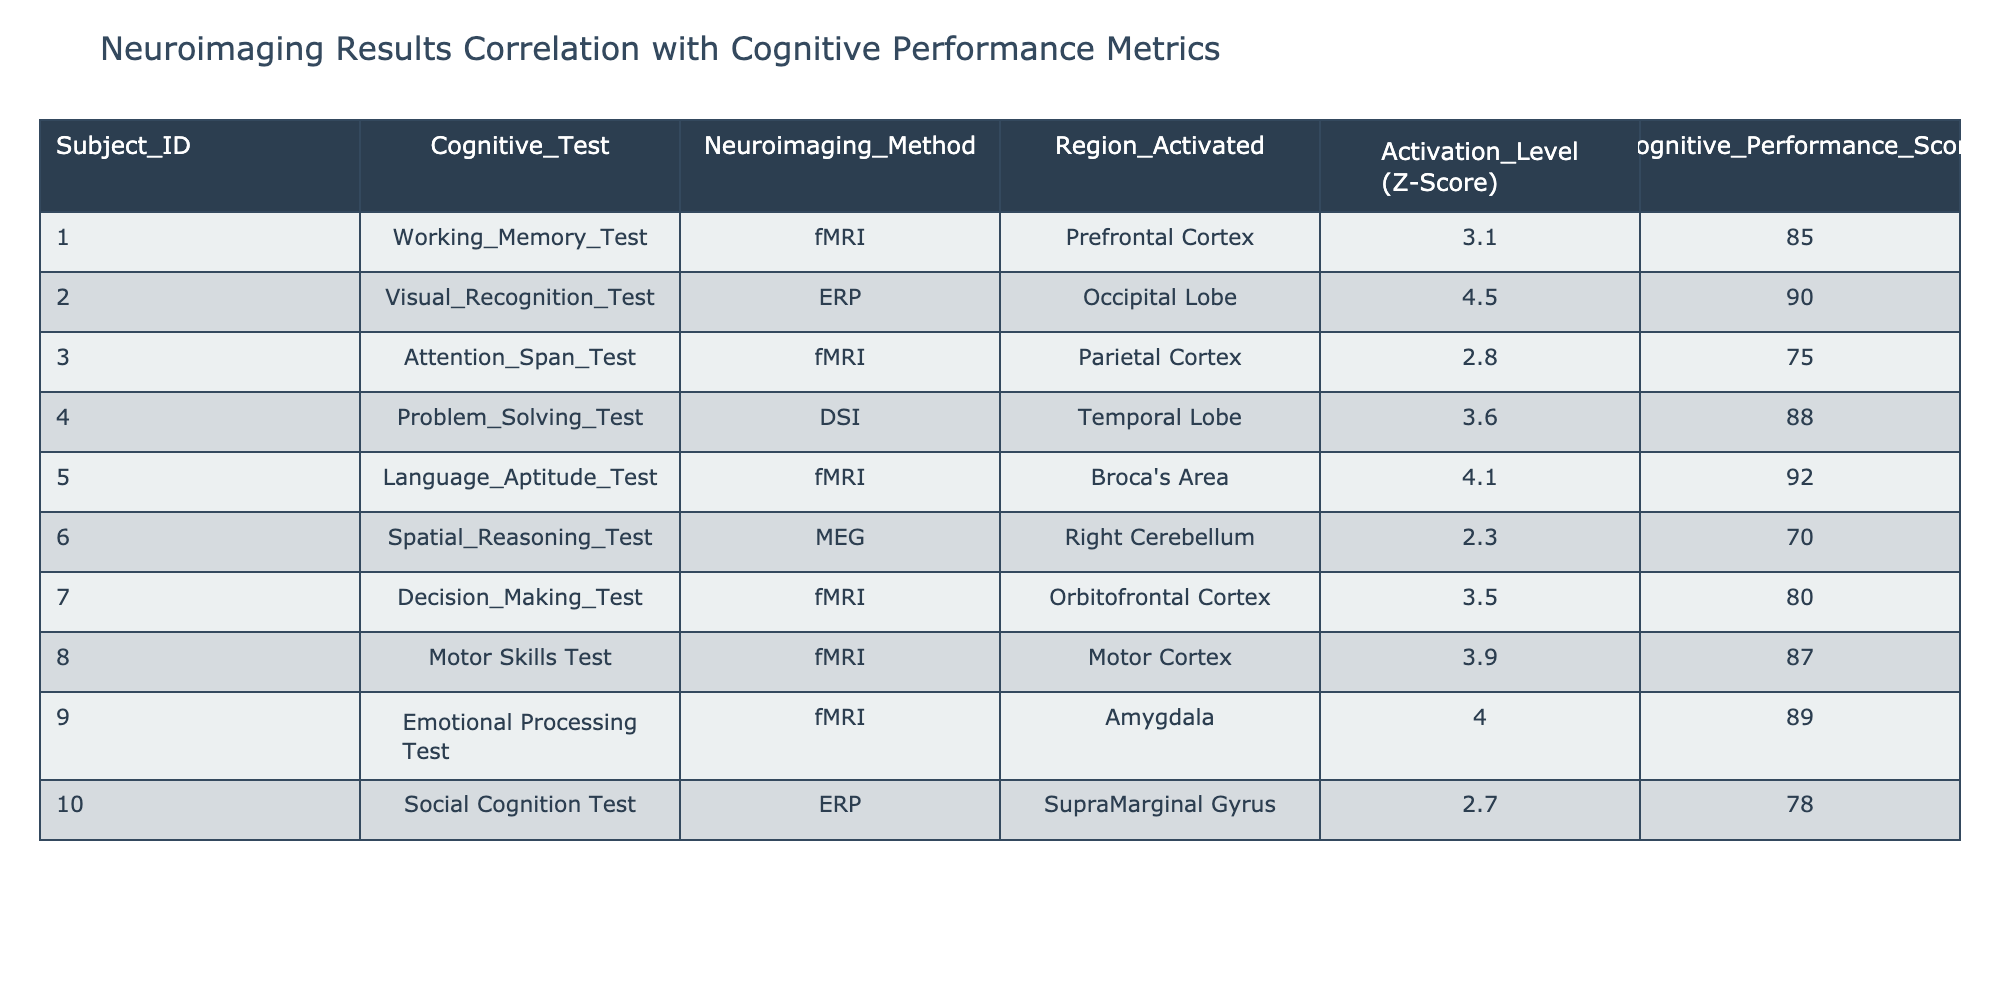What is the cognitive performance score associated with the visual recognition test? The cognitive performance score for the subject who took the visual recognition test (Subject ID 002) is directly listed in the table under the Cognitive Performance Score column. It shows a score of 90.
Answer: 90 Which neuroimaging method is used for the problem-solving test? The problem-solving test is associated with the neuroimaging method DSI, as indicated by the entry for Subject ID 004 in the Neuroimaging Method column.
Answer: DSI What is the average activation level (Z-Score) across all cognitive tests? To find the average, add all the activation levels (3.1 + 4.5 + 2.8 + 3.6 + 4.1 + 2.3 + 3.5 + 3.9 + 4.0 + 2.7 = 33.5) and divide by the number of tests (10). Thus, the average is 33.5 / 10 = 3.35.
Answer: 3.35 Is there a test where the activation level exceeds 4.0? By reviewing the Activation Level column, we see that the visual recognition test (4.5), language aptitude test (4.1), and emotional processing test (4.0) have activation levels greater than 4.0. Therefore, the answer is yes.
Answer: Yes Which region has the highest activation level and what is that level? By examining the Activation Level column, the highest value is 4.5, associated with the region activated in the visual recognition test (Occipital Lobe). This value is higher than any other entry in the table.
Answer: 4.5 (Occipital Lobe) How many cognitive tests have a performance score above 85? The cognitive performance scores higher than 85 are: Working Memory Test (85), Visual Recognition Test (90), Problem Solving Test (88), Language Aptitude Test (92), Motor Skills Test (87), and Emotional Processing Test (89), resulting in 6 tests above or equal to 85.
Answer: 6 What is the difference in activation levels between the language aptitude test and spatial reasoning test? For the language aptitude test, the activation level is 4.1. For the spatial reasoning test, the activation level is 2.3. The difference is calculated as 4.1 - 2.3 = 1.8.
Answer: 1.8 Is the activation level in the motor skills test lower than the average activation level of 3.35? The activation level for the motor skills test is 3.9. Since 3.9 is greater than 3.35, the statement is false.
Answer: No Which subject had the lowest cognitive performance score? The cognitive performance score associated with the spatial reasoning test (Subject ID 006) is 70, which is the lowest score when comparing all subjects' performance scores in the table.
Answer: 70 